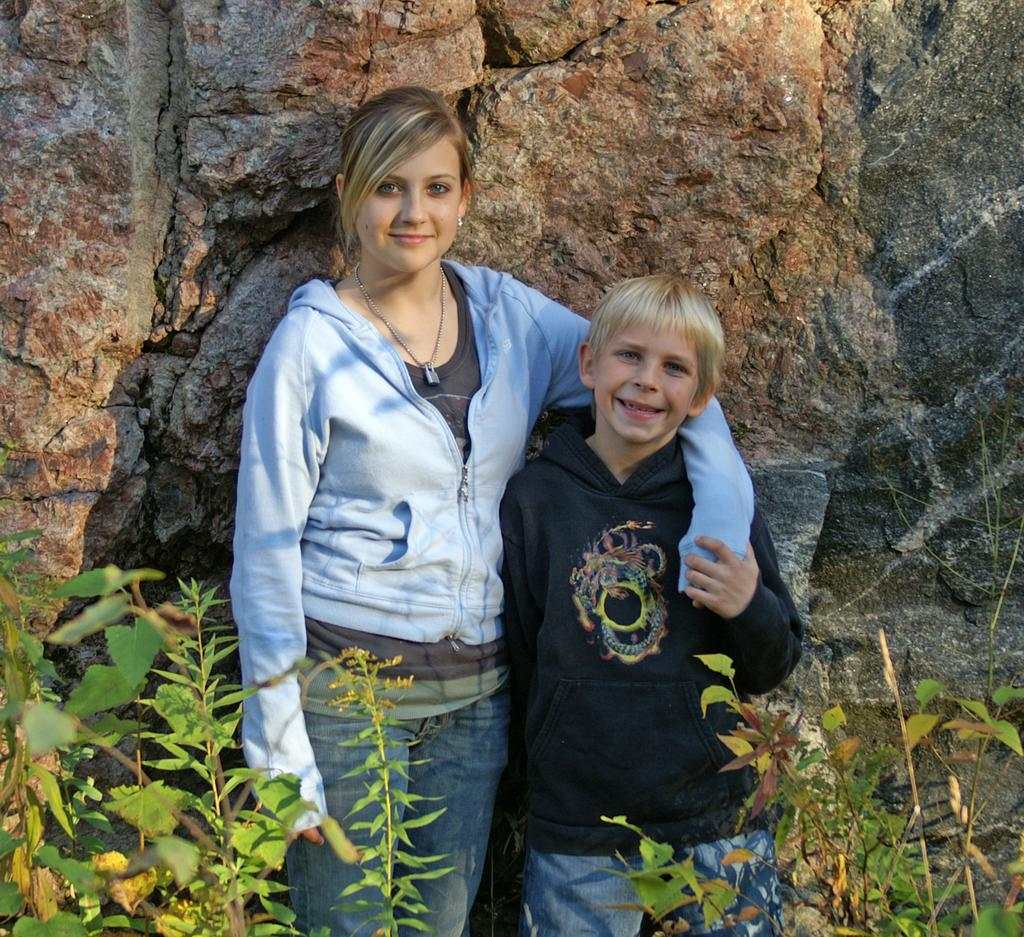Who are the people in the image? There is a woman and a boy in the image. What are the woman and the boy doing in the image? Both the woman and the boy are standing and smiling. What is visible in the background of the image? There are rocks behind them. What can be seen on either side of the image? There are plants on either side of the image. What type of connection can be seen between the woman and the boy in the image? There is no specific connection mentioned or depicted between the woman and the boy in the image. What kind of voyage are the woman and the boy embarking on in the image? There is no indication of a voyage or any travel-related activity in the image. 